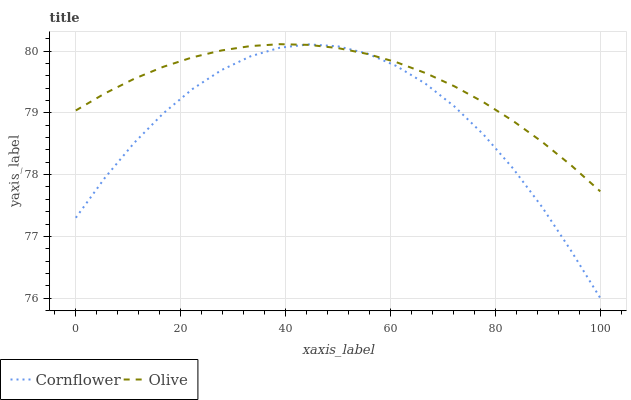Does Cornflower have the minimum area under the curve?
Answer yes or no. Yes. Does Olive have the maximum area under the curve?
Answer yes or no. Yes. Does Cornflower have the maximum area under the curve?
Answer yes or no. No. Is Olive the smoothest?
Answer yes or no. Yes. Is Cornflower the roughest?
Answer yes or no. Yes. Is Cornflower the smoothest?
Answer yes or no. No. Does Cornflower have the lowest value?
Answer yes or no. Yes. Does Olive have the highest value?
Answer yes or no. Yes. Does Cornflower have the highest value?
Answer yes or no. No. Does Olive intersect Cornflower?
Answer yes or no. Yes. Is Olive less than Cornflower?
Answer yes or no. No. Is Olive greater than Cornflower?
Answer yes or no. No. 